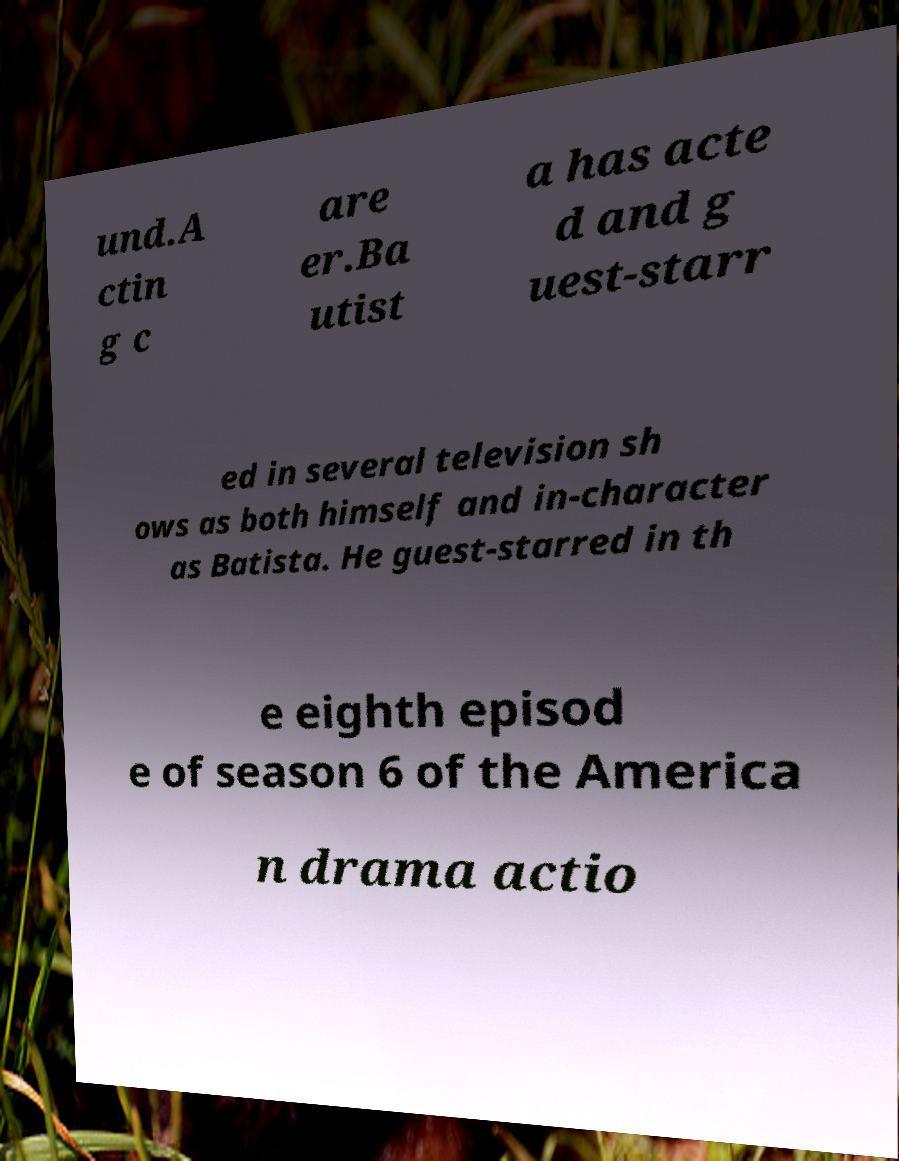Please identify and transcribe the text found in this image. und.A ctin g c are er.Ba utist a has acte d and g uest-starr ed in several television sh ows as both himself and in-character as Batista. He guest-starred in th e eighth episod e of season 6 of the America n drama actio 